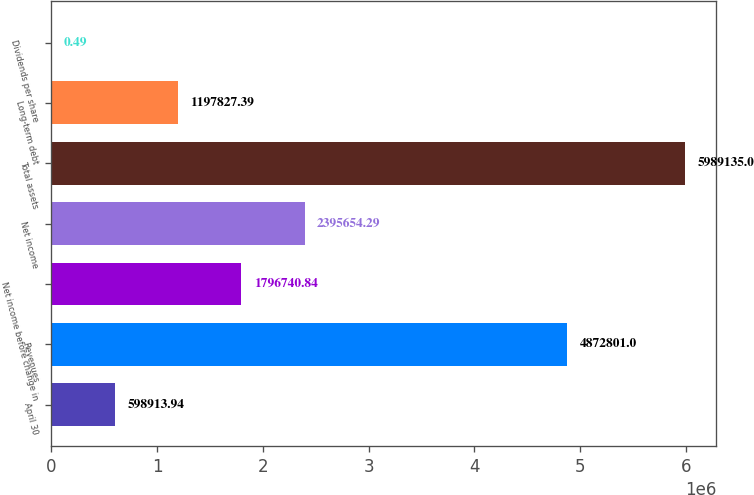<chart> <loc_0><loc_0><loc_500><loc_500><bar_chart><fcel>April 30<fcel>Revenues<fcel>Net income before change in<fcel>Net income<fcel>Total assets<fcel>Long-term debt<fcel>Dividends per share<nl><fcel>598914<fcel>4.8728e+06<fcel>1.79674e+06<fcel>2.39565e+06<fcel>5.98914e+06<fcel>1.19783e+06<fcel>0.49<nl></chart> 